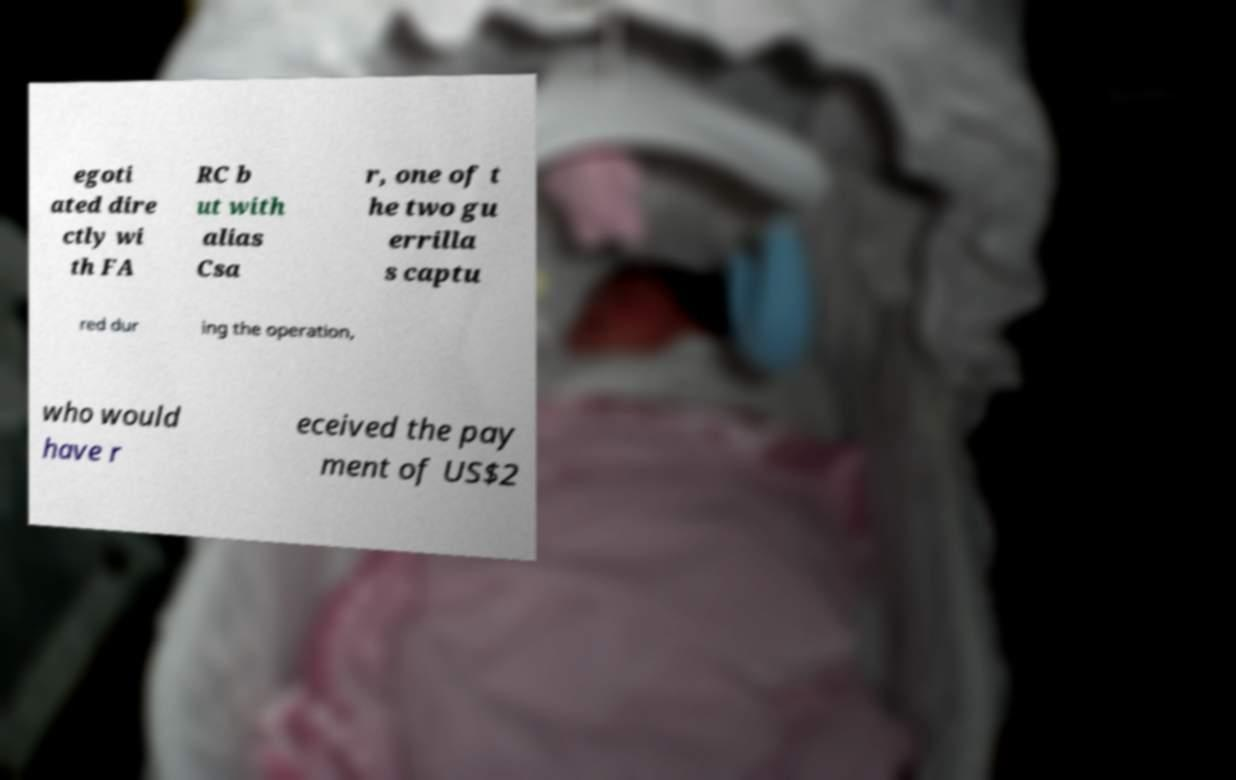Can you accurately transcribe the text from the provided image for me? egoti ated dire ctly wi th FA RC b ut with alias Csa r, one of t he two gu errilla s captu red dur ing the operation, who would have r eceived the pay ment of US$2 